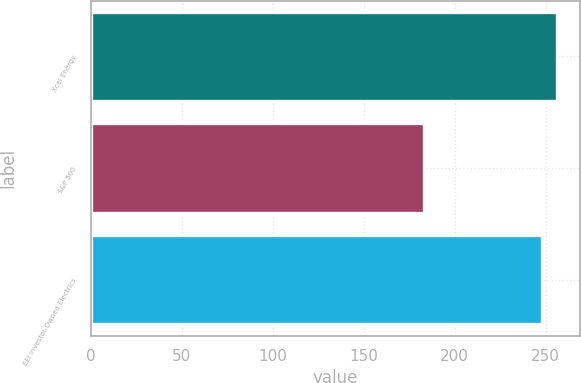Convert chart. <chart><loc_0><loc_0><loc_500><loc_500><bar_chart><fcel>Xcel Energy<fcel>S&P 500<fcel>EEI Investor-Owned Electrics<nl><fcel>256<fcel>183<fcel>248<nl></chart> 